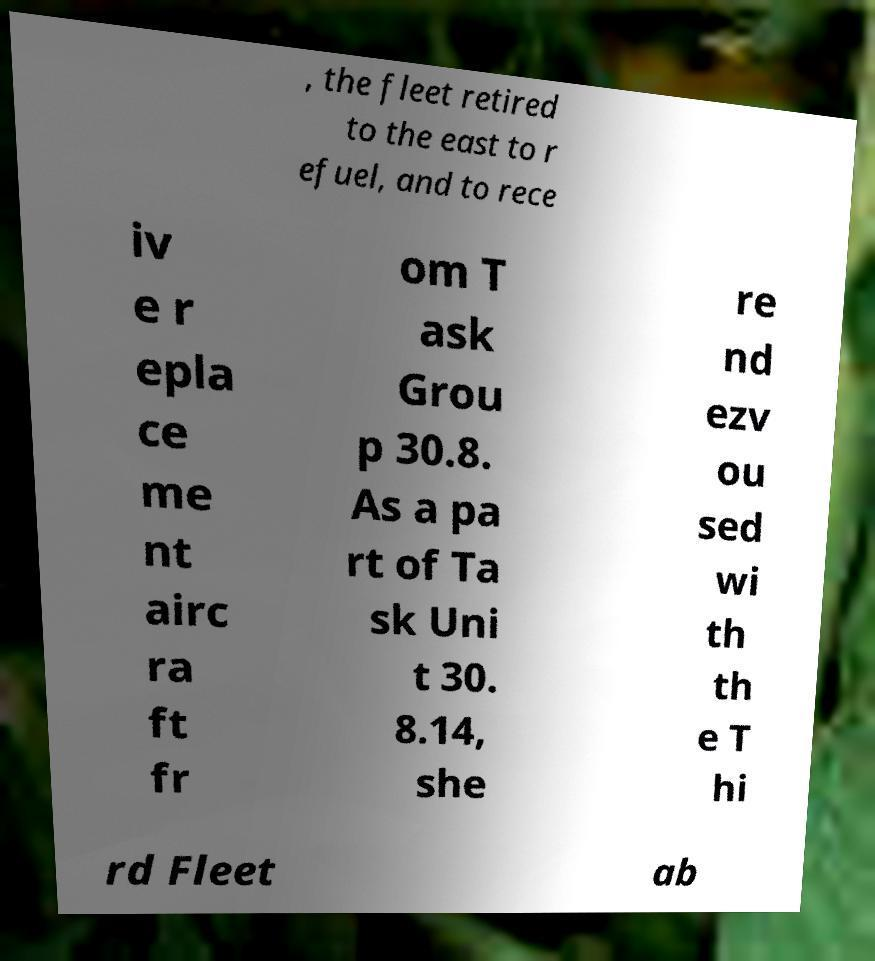Could you assist in decoding the text presented in this image and type it out clearly? , the fleet retired to the east to r efuel, and to rece iv e r epla ce me nt airc ra ft fr om T ask Grou p 30.8. As a pa rt of Ta sk Uni t 30. 8.14, she re nd ezv ou sed wi th th e T hi rd Fleet ab 